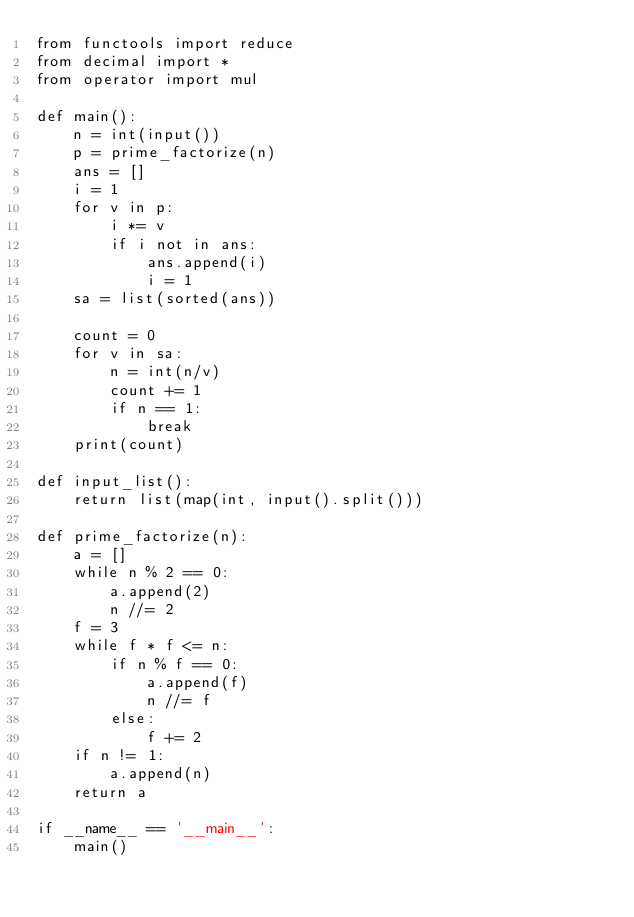<code> <loc_0><loc_0><loc_500><loc_500><_Python_>from functools import reduce
from decimal import *
from operator import mul

def main():
    n = int(input())
    p = prime_factorize(n)
    ans = []
    i = 1
    for v in p:
        i *= v
        if i not in ans:
            ans.append(i)
            i = 1
    sa = list(sorted(ans))

    count = 0
    for v in sa:
        n = int(n/v)
        count += 1
        if n == 1:
            break
    print(count)

def input_list():
    return list(map(int, input().split()))

def prime_factorize(n):
    a = []
    while n % 2 == 0:
        a.append(2)
        n //= 2
    f = 3
    while f * f <= n:
        if n % f == 0:
            a.append(f)
            n //= f
        else:
            f += 2
    if n != 1:
        a.append(n)
    return a

if __name__ == '__main__':
    main()
</code> 